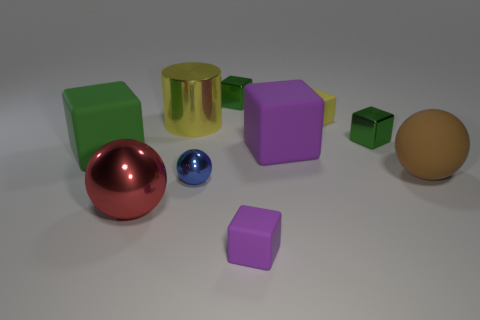Are there any red metallic things that have the same shape as the large purple rubber thing?
Give a very brief answer. No. What shape is the big red shiny object?
Offer a terse response. Sphere. What number of things are either gray cylinders or tiny green metallic objects?
Offer a very short reply. 2. Does the object that is in front of the large red thing have the same size as the green cube on the left side of the big yellow shiny cylinder?
Provide a succinct answer. No. How many other objects are the same material as the cylinder?
Offer a terse response. 4. Is the number of large green matte objects that are behind the matte sphere greater than the number of purple things that are behind the large metal cylinder?
Your answer should be very brief. Yes. What material is the tiny cube that is on the left side of the tiny purple object?
Give a very brief answer. Metal. Does the red object have the same shape as the blue metal thing?
Make the answer very short. Yes. Are there any other things that have the same color as the big shiny ball?
Your answer should be compact. No. What is the color of the other big object that is the same shape as the big red thing?
Provide a succinct answer. Brown. 